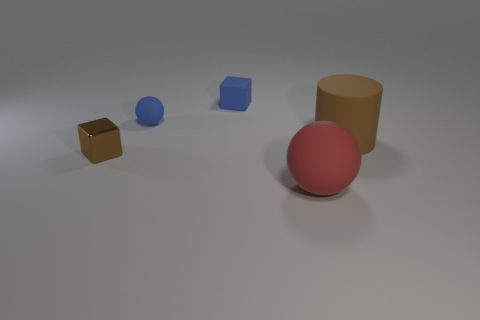Add 1 shiny things. How many objects exist? 6 Subtract all cubes. How many objects are left? 3 Subtract 0 green cylinders. How many objects are left? 5 Subtract all large gray cylinders. Subtract all large brown rubber cylinders. How many objects are left? 4 Add 4 small blue spheres. How many small blue spheres are left? 5 Add 5 tiny blue matte spheres. How many tiny blue matte spheres exist? 6 